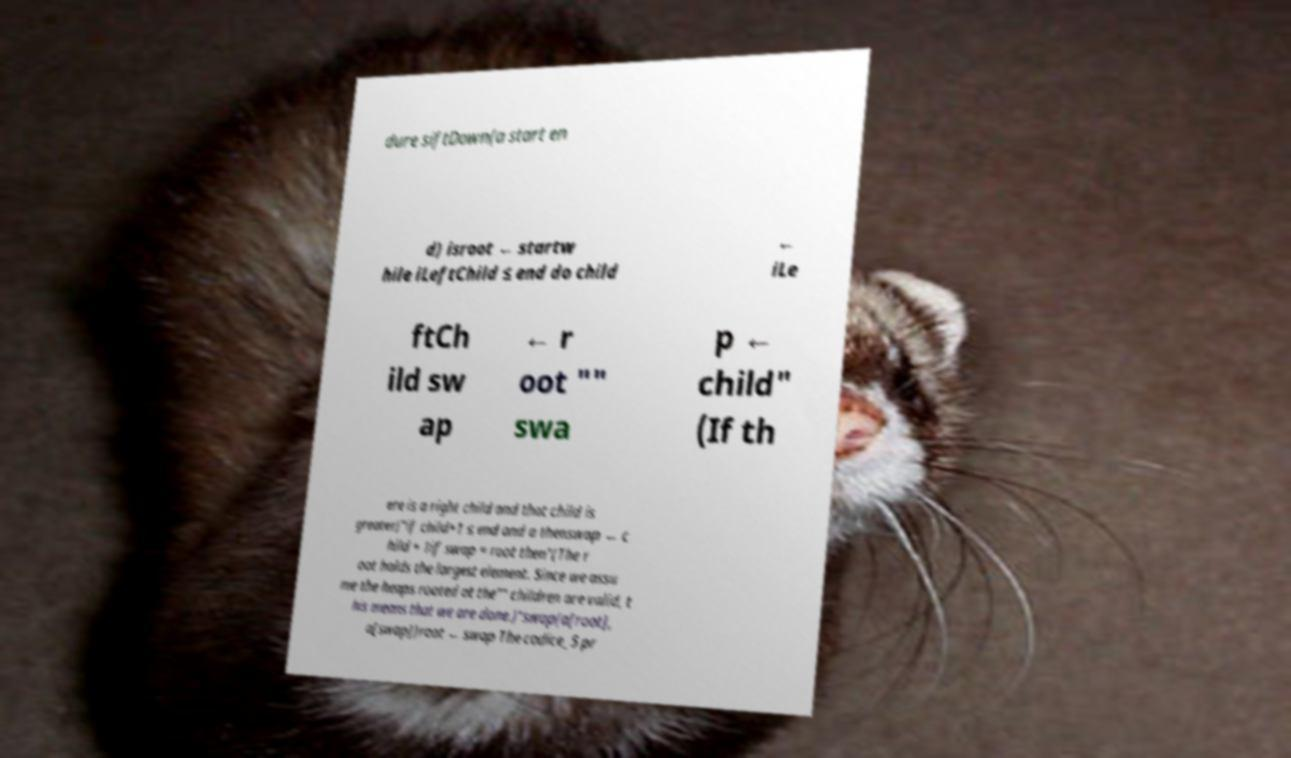Please identify and transcribe the text found in this image. dure siftDown(a start en d) isroot ← startw hile iLeftChild ≤ end do child ← iLe ftCh ild sw ap ← r oot "" swa p ← child" (If th ere is a right child and that child is greater)"if child+1 ≤ end and a thenswap ← c hild + 1if swap = root then"(The r oot holds the largest element. Since we assu me the heaps rooted at the"" children are valid, t his means that we are done.)"swap(a[root], a[swap])root ← swap The codice_5 pr 